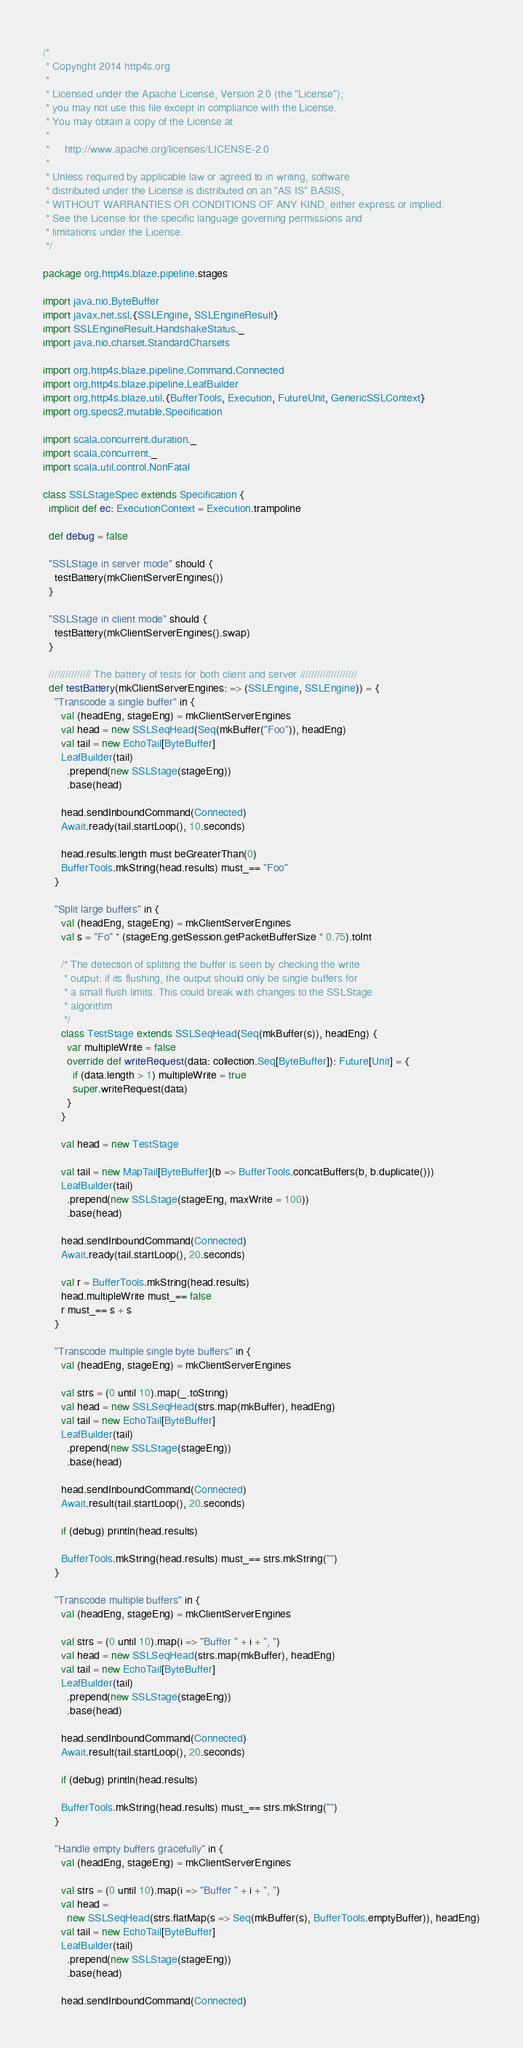Convert code to text. <code><loc_0><loc_0><loc_500><loc_500><_Scala_>/*
 * Copyright 2014 http4s.org
 *
 * Licensed under the Apache License, Version 2.0 (the "License");
 * you may not use this file except in compliance with the License.
 * You may obtain a copy of the License at
 *
 *     http://www.apache.org/licenses/LICENSE-2.0
 *
 * Unless required by applicable law or agreed to in writing, software
 * distributed under the License is distributed on an "AS IS" BASIS,
 * WITHOUT WARRANTIES OR CONDITIONS OF ANY KIND, either express or implied.
 * See the License for the specific language governing permissions and
 * limitations under the License.
 */

package org.http4s.blaze.pipeline.stages

import java.nio.ByteBuffer
import javax.net.ssl.{SSLEngine, SSLEngineResult}
import SSLEngineResult.HandshakeStatus._
import java.nio.charset.StandardCharsets

import org.http4s.blaze.pipeline.Command.Connected
import org.http4s.blaze.pipeline.LeafBuilder
import org.http4s.blaze.util.{BufferTools, Execution, FutureUnit, GenericSSLContext}
import org.specs2.mutable.Specification

import scala.concurrent.duration._
import scala.concurrent._
import scala.util.control.NonFatal

class SSLStageSpec extends Specification {
  implicit def ec: ExecutionContext = Execution.trampoline

  def debug = false

  "SSLStage in server mode" should {
    testBattery(mkClientServerEngines())
  }

  "SSLStage in client mode" should {
    testBattery(mkClientServerEngines().swap)
  }

  /////////////// The battery of tests for both client and server ////////////////////
  def testBattery(mkClientServerEngines: => (SSLEngine, SSLEngine)) = {
    "Transcode a single buffer" in {
      val (headEng, stageEng) = mkClientServerEngines
      val head = new SSLSeqHead(Seq(mkBuffer("Foo")), headEng)
      val tail = new EchoTail[ByteBuffer]
      LeafBuilder(tail)
        .prepend(new SSLStage(stageEng))
        .base(head)

      head.sendInboundCommand(Connected)
      Await.ready(tail.startLoop(), 10.seconds)

      head.results.length must beGreaterThan(0)
      BufferTools.mkString(head.results) must_== "Foo"
    }

    "Split large buffers" in {
      val (headEng, stageEng) = mkClientServerEngines
      val s = "Fo" * (stageEng.getSession.getPacketBufferSize * 0.75).toInt

      /* The detection of splitting the buffer is seen by checking the write
       * output: if its flushing, the output should only be single buffers for
       * a small flush limits. This could break with changes to the SSLStage
       * algorithm
       */
      class TestStage extends SSLSeqHead(Seq(mkBuffer(s)), headEng) {
        var multipleWrite = false
        override def writeRequest(data: collection.Seq[ByteBuffer]): Future[Unit] = {
          if (data.length > 1) multipleWrite = true
          super.writeRequest(data)
        }
      }

      val head = new TestStage

      val tail = new MapTail[ByteBuffer](b => BufferTools.concatBuffers(b, b.duplicate()))
      LeafBuilder(tail)
        .prepend(new SSLStage(stageEng, maxWrite = 100))
        .base(head)

      head.sendInboundCommand(Connected)
      Await.ready(tail.startLoop(), 20.seconds)

      val r = BufferTools.mkString(head.results)
      head.multipleWrite must_== false
      r must_== s + s
    }

    "Transcode multiple single byte buffers" in {
      val (headEng, stageEng) = mkClientServerEngines

      val strs = (0 until 10).map(_.toString)
      val head = new SSLSeqHead(strs.map(mkBuffer), headEng)
      val tail = new EchoTail[ByteBuffer]
      LeafBuilder(tail)
        .prepend(new SSLStage(stageEng))
        .base(head)

      head.sendInboundCommand(Connected)
      Await.result(tail.startLoop(), 20.seconds)

      if (debug) println(head.results)

      BufferTools.mkString(head.results) must_== strs.mkString("")
    }

    "Transcode multiple buffers" in {
      val (headEng, stageEng) = mkClientServerEngines

      val strs = (0 until 10).map(i => "Buffer " + i + ", ")
      val head = new SSLSeqHead(strs.map(mkBuffer), headEng)
      val tail = new EchoTail[ByteBuffer]
      LeafBuilder(tail)
        .prepend(new SSLStage(stageEng))
        .base(head)

      head.sendInboundCommand(Connected)
      Await.result(tail.startLoop(), 20.seconds)

      if (debug) println(head.results)

      BufferTools.mkString(head.results) must_== strs.mkString("")
    }

    "Handle empty buffers gracefully" in {
      val (headEng, stageEng) = mkClientServerEngines

      val strs = (0 until 10).map(i => "Buffer " + i + ", ")
      val head =
        new SSLSeqHead(strs.flatMap(s => Seq(mkBuffer(s), BufferTools.emptyBuffer)), headEng)
      val tail = new EchoTail[ByteBuffer]
      LeafBuilder(tail)
        .prepend(new SSLStage(stageEng))
        .base(head)

      head.sendInboundCommand(Connected)</code> 